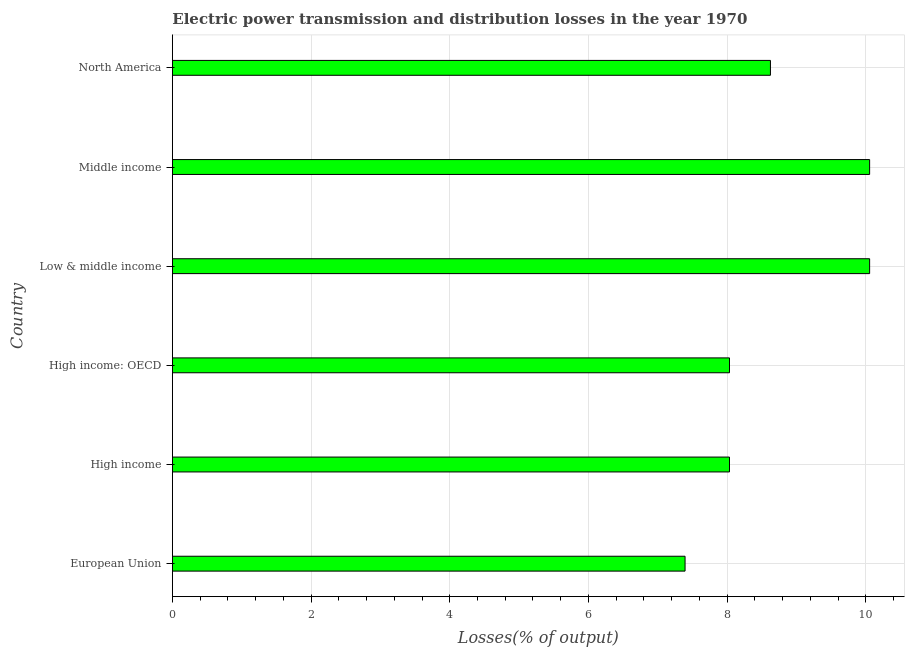Does the graph contain grids?
Your answer should be very brief. Yes. What is the title of the graph?
Provide a succinct answer. Electric power transmission and distribution losses in the year 1970. What is the label or title of the X-axis?
Offer a very short reply. Losses(% of output). What is the electric power transmission and distribution losses in Middle income?
Your answer should be very brief. 10.05. Across all countries, what is the maximum electric power transmission and distribution losses?
Make the answer very short. 10.05. Across all countries, what is the minimum electric power transmission and distribution losses?
Your answer should be very brief. 7.39. What is the sum of the electric power transmission and distribution losses?
Ensure brevity in your answer.  52.19. What is the difference between the electric power transmission and distribution losses in Low & middle income and North America?
Provide a short and direct response. 1.43. What is the average electric power transmission and distribution losses per country?
Make the answer very short. 8.7. What is the median electric power transmission and distribution losses?
Provide a short and direct response. 8.33. What is the ratio of the electric power transmission and distribution losses in Low & middle income to that in North America?
Ensure brevity in your answer.  1.17. Is the electric power transmission and distribution losses in High income less than that in North America?
Your answer should be compact. Yes. Is the difference between the electric power transmission and distribution losses in High income and Low & middle income greater than the difference between any two countries?
Provide a short and direct response. No. Is the sum of the electric power transmission and distribution losses in European Union and High income: OECD greater than the maximum electric power transmission and distribution losses across all countries?
Give a very brief answer. Yes. What is the difference between the highest and the lowest electric power transmission and distribution losses?
Offer a very short reply. 2.66. What is the Losses(% of output) in European Union?
Your answer should be compact. 7.39. What is the Losses(% of output) in High income?
Give a very brief answer. 8.03. What is the Losses(% of output) of High income: OECD?
Ensure brevity in your answer.  8.03. What is the Losses(% of output) in Low & middle income?
Provide a succinct answer. 10.05. What is the Losses(% of output) in Middle income?
Offer a very short reply. 10.05. What is the Losses(% of output) in North America?
Keep it short and to the point. 8.62. What is the difference between the Losses(% of output) in European Union and High income?
Make the answer very short. -0.64. What is the difference between the Losses(% of output) in European Union and High income: OECD?
Give a very brief answer. -0.64. What is the difference between the Losses(% of output) in European Union and Low & middle income?
Provide a succinct answer. -2.66. What is the difference between the Losses(% of output) in European Union and Middle income?
Offer a terse response. -2.66. What is the difference between the Losses(% of output) in European Union and North America?
Make the answer very short. -1.23. What is the difference between the Losses(% of output) in High income and High income: OECD?
Offer a very short reply. 0. What is the difference between the Losses(% of output) in High income and Low & middle income?
Your answer should be very brief. -2.02. What is the difference between the Losses(% of output) in High income and Middle income?
Make the answer very short. -2.02. What is the difference between the Losses(% of output) in High income and North America?
Offer a very short reply. -0.59. What is the difference between the Losses(% of output) in High income: OECD and Low & middle income?
Offer a very short reply. -2.02. What is the difference between the Losses(% of output) in High income: OECD and Middle income?
Your answer should be very brief. -2.02. What is the difference between the Losses(% of output) in High income: OECD and North America?
Your response must be concise. -0.59. What is the difference between the Losses(% of output) in Low & middle income and Middle income?
Offer a terse response. 0. What is the difference between the Losses(% of output) in Low & middle income and North America?
Provide a short and direct response. 1.43. What is the difference between the Losses(% of output) in Middle income and North America?
Offer a terse response. 1.43. What is the ratio of the Losses(% of output) in European Union to that in High income?
Your answer should be compact. 0.92. What is the ratio of the Losses(% of output) in European Union to that in Low & middle income?
Your response must be concise. 0.73. What is the ratio of the Losses(% of output) in European Union to that in Middle income?
Make the answer very short. 0.73. What is the ratio of the Losses(% of output) in European Union to that in North America?
Keep it short and to the point. 0.86. What is the ratio of the Losses(% of output) in High income to that in High income: OECD?
Give a very brief answer. 1. What is the ratio of the Losses(% of output) in High income to that in Low & middle income?
Offer a very short reply. 0.8. What is the ratio of the Losses(% of output) in High income to that in Middle income?
Your answer should be compact. 0.8. What is the ratio of the Losses(% of output) in High income to that in North America?
Ensure brevity in your answer.  0.93. What is the ratio of the Losses(% of output) in High income: OECD to that in Low & middle income?
Give a very brief answer. 0.8. What is the ratio of the Losses(% of output) in High income: OECD to that in Middle income?
Provide a short and direct response. 0.8. What is the ratio of the Losses(% of output) in High income: OECD to that in North America?
Your answer should be very brief. 0.93. What is the ratio of the Losses(% of output) in Low & middle income to that in Middle income?
Give a very brief answer. 1. What is the ratio of the Losses(% of output) in Low & middle income to that in North America?
Give a very brief answer. 1.17. What is the ratio of the Losses(% of output) in Middle income to that in North America?
Make the answer very short. 1.17. 